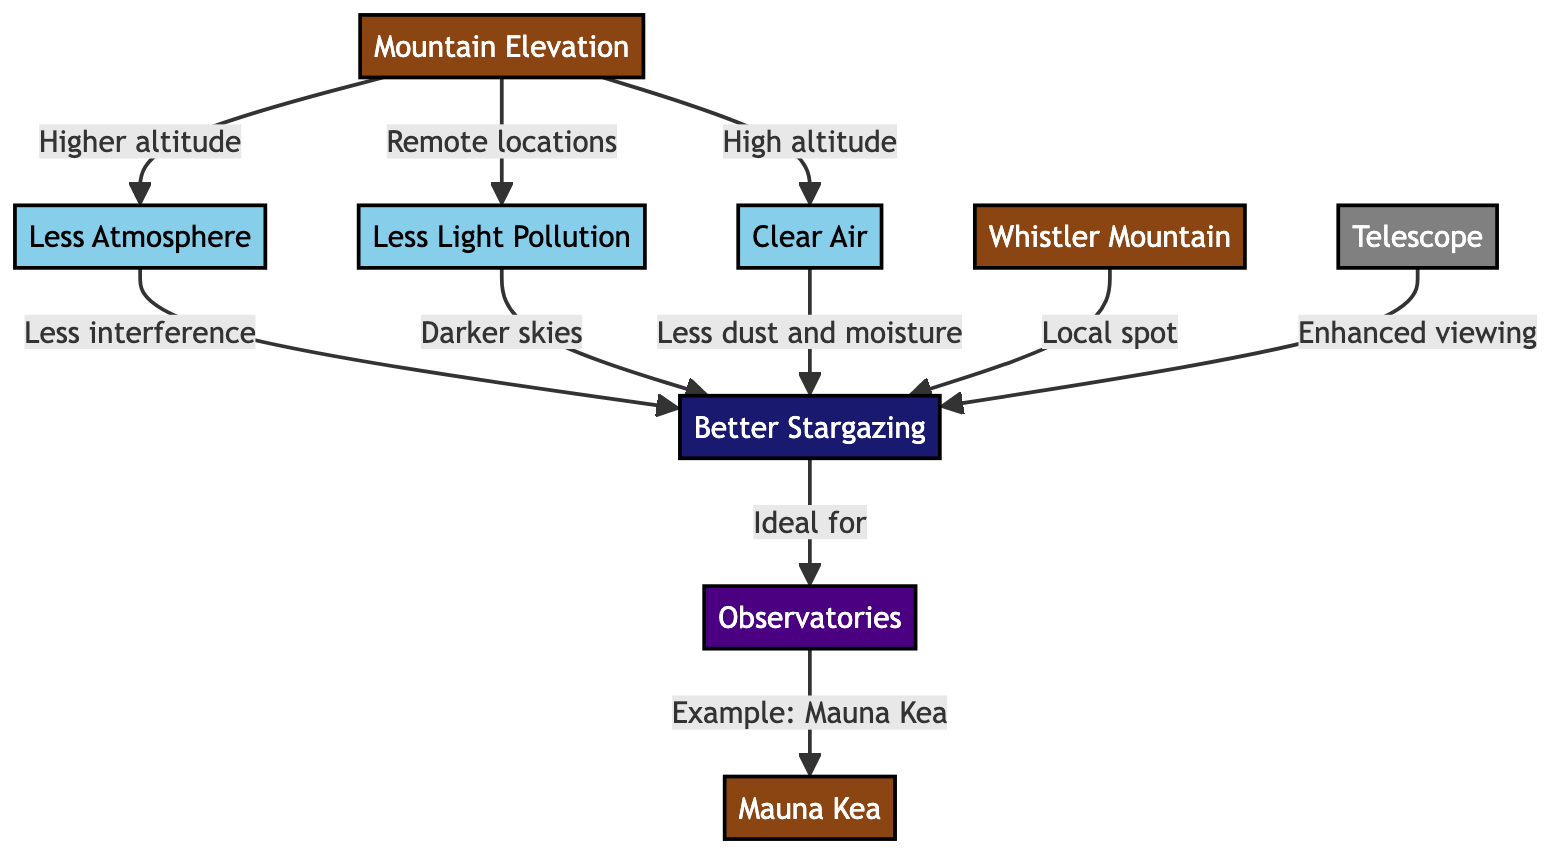What creates better stargazing from higher altitudes? Higher altitudes lead to less atmosphere, less light pollution, and clearer air. This combination results in better stargazing conditions as there is less interference, darker skies, and reduced dust and moisture.
Answer: Less atmosphere, less light pollution, clear air How many nodes are in the diagram? The diagram contains ten distinct nodes: Mountain Elevation, Less Atmosphere, Less Light Pollution, Clear Air, Better Stargazing, Observatories, Whistler Mountain, Mauna Kea, Telescope, and one additional node represented as a title.
Answer: Ten nodes Which mountain is a local spot for better stargazing? The diagram indicates that Whistler Mountain is identified as a local spot for better stargazing. This is explicitly stated in the flow from Better Stargazing to Whistler Mountain.
Answer: Whistler Mountain What kind of telescope enhances viewing for better stargazing? The diagram indicates that a telescope is used for enhanced viewing, contributing to the ideal conditions for better stargazing. The node "Telescope" is connected to the better stargazing outcome.
Answer: Telescope What is an example of an observatory mentioned in the diagram? The diagram highlights Mauna Kea as an example of an observatory. This connection is made from the node Observatories, which flows into an example label.
Answer: Mauna Kea How do remote locations contribute to better stargazing? Remote locations provide less light pollution, which translates to darker skies. This reduction in light interference improves the overall stargazing experience, as described in the connection from mountain elevation to better stargazing through less light pollution.
Answer: Less light pollution 